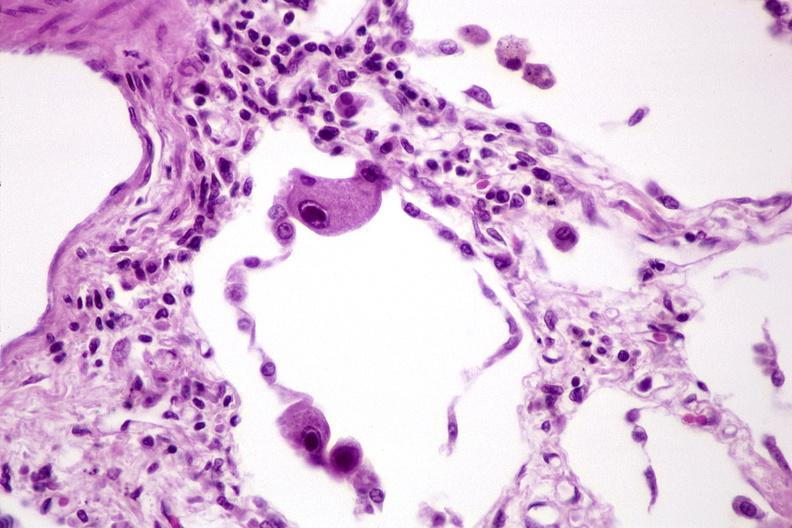s respiratory present?
Answer the question using a single word or phrase. Yes 